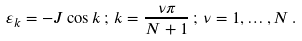<formula> <loc_0><loc_0><loc_500><loc_500>\varepsilon _ { k } = - J \cos k \, ; \, k = \frac { \nu \pi } { N + 1 } \, ; \, \nu = 1 , \dots , N \, .</formula> 